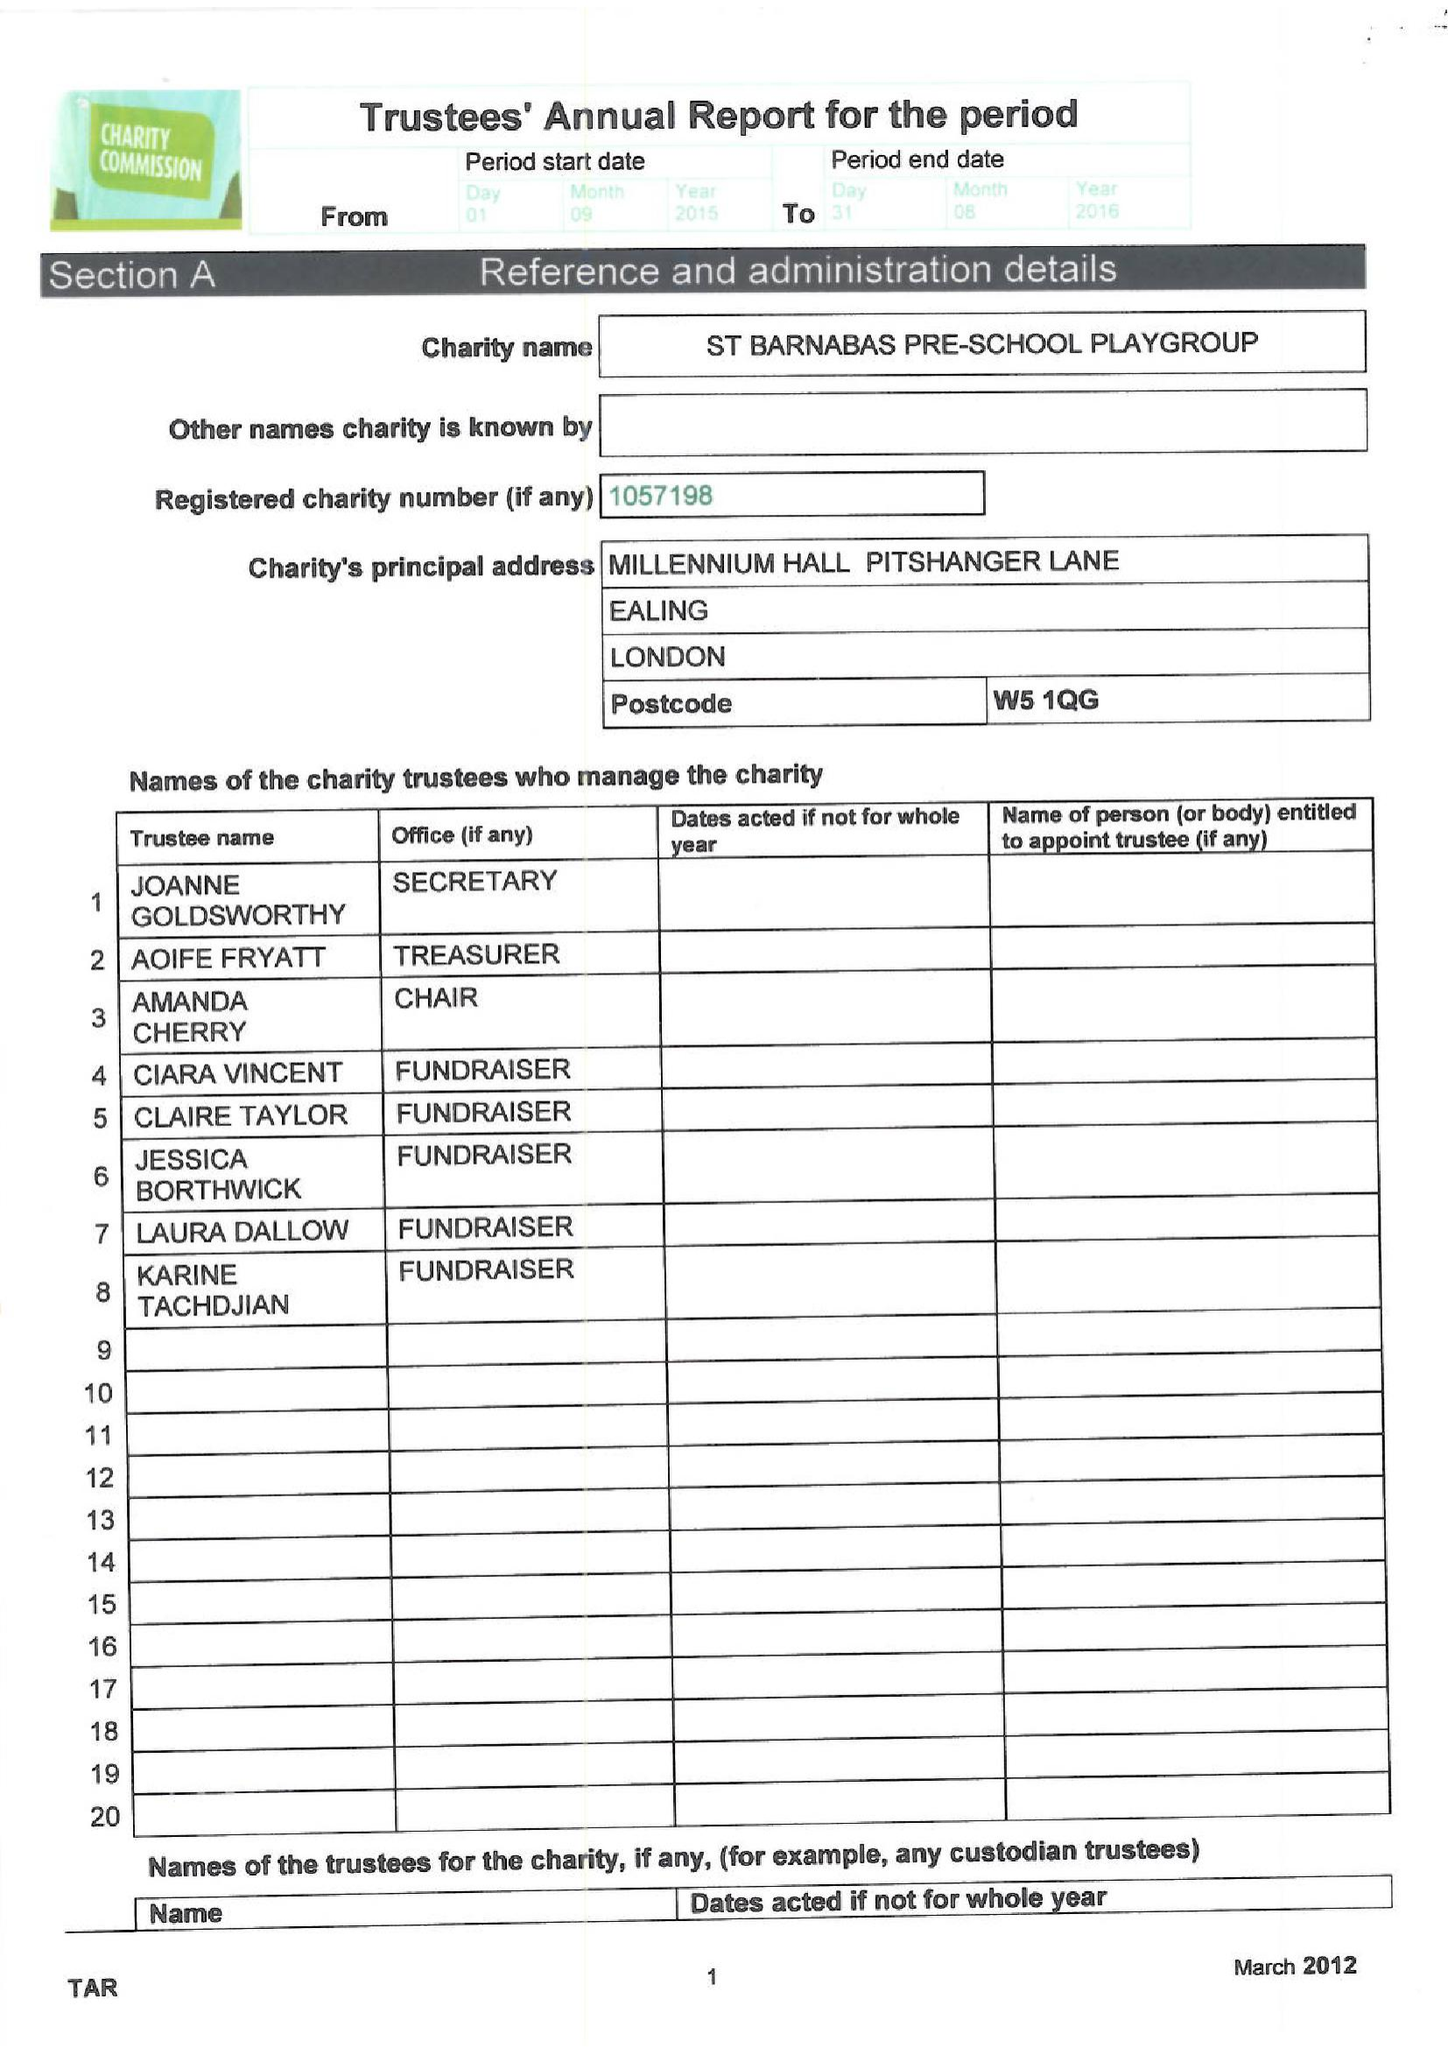What is the value for the income_annually_in_british_pounds?
Answer the question using a single word or phrase. 56596.00 